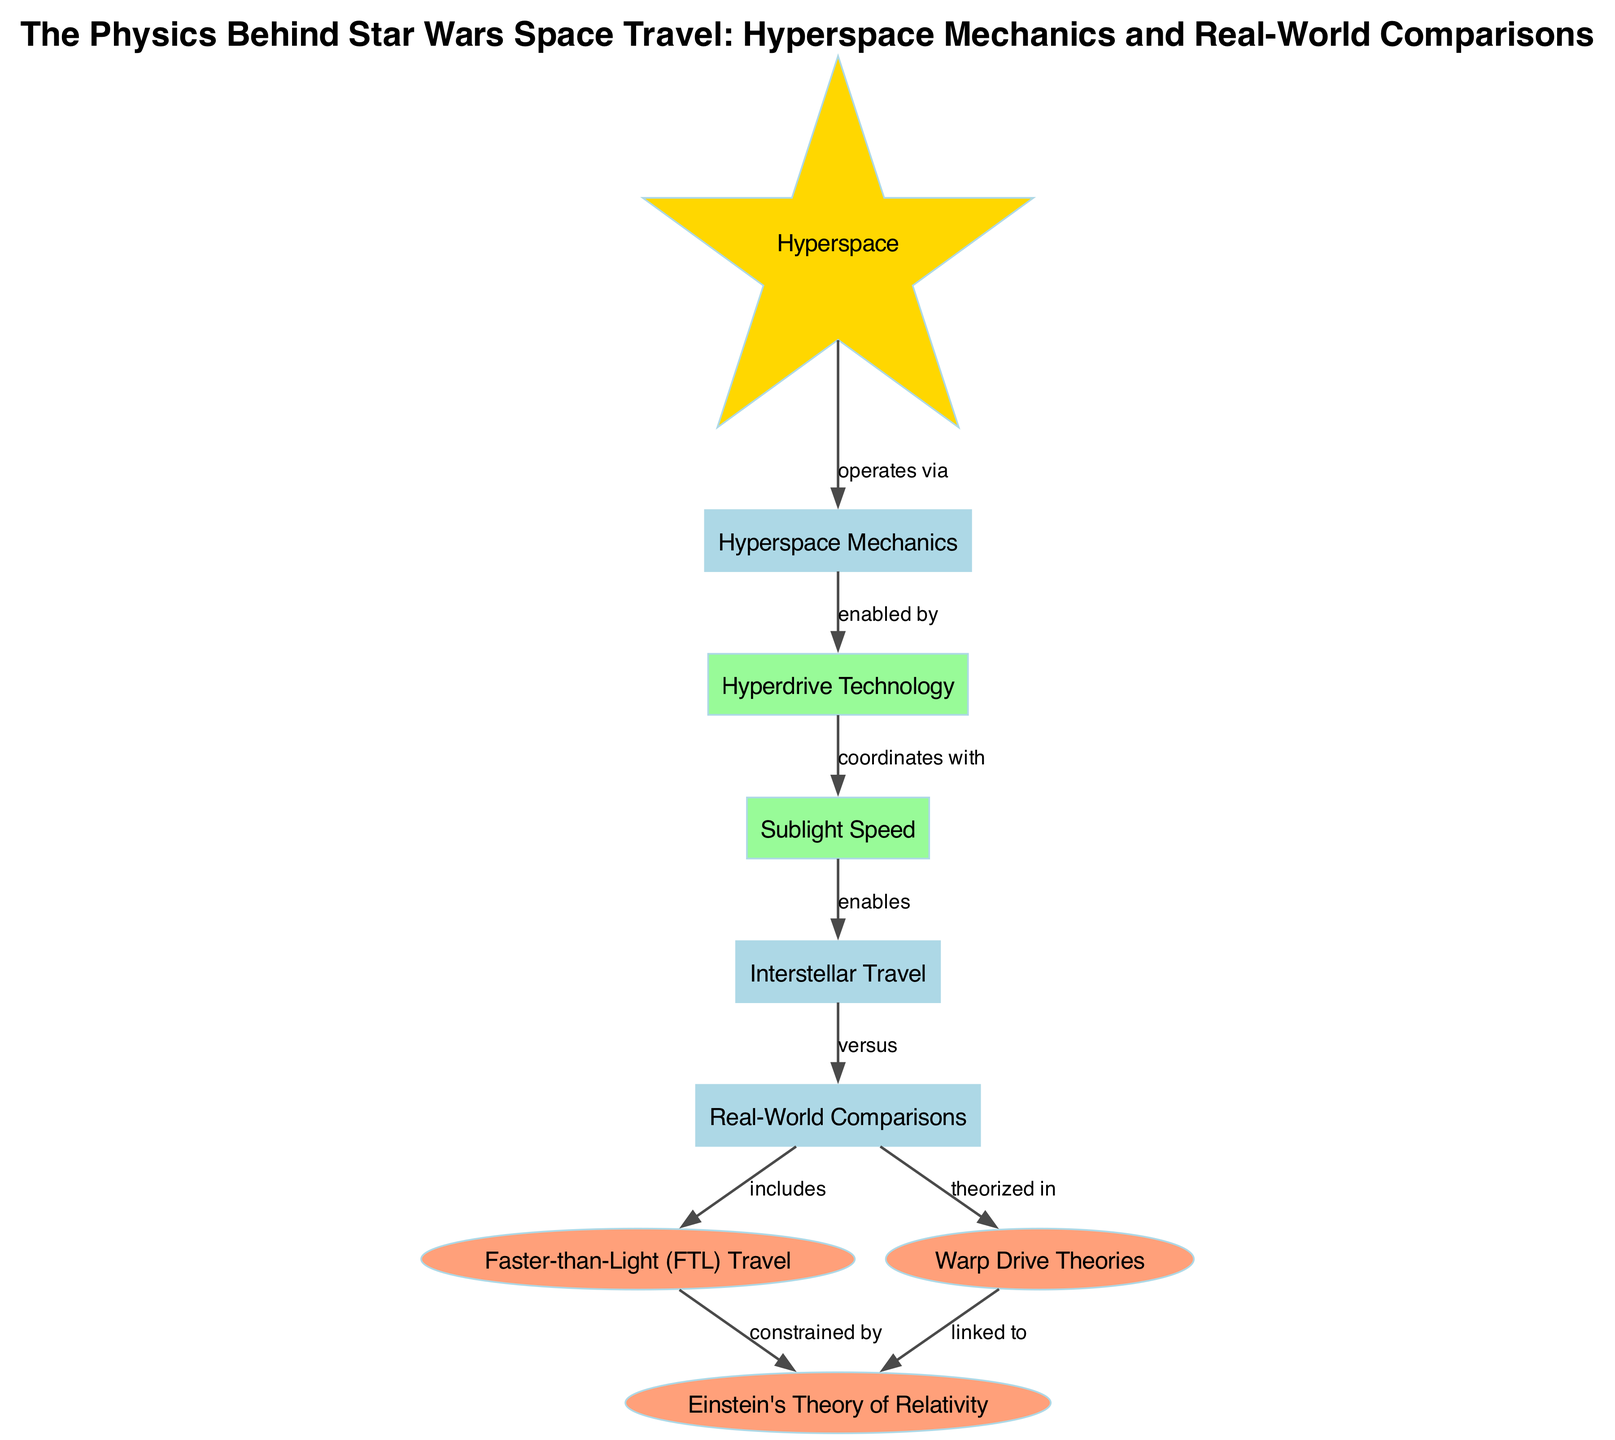What is the main concept represented at the top of the diagram? The top node of the diagram is labeled "Hyperspace," indicating it is the main concept or focus of the diagram.
Answer: Hyperspace How many nodes are present in the diagram? By counting each unique node listed, the diagram includes a total of 9 nodes, which represent different aspects of hyperspace and space travel.
Answer: 9 Which node is enabled by hyperspace mechanics? Referring to the edge that connects "hyperspace mechanics" to "hyperdrive technology," it indicates that hyperdrive technology is enabled by hyperspace mechanics.
Answer: Hyperdrive Technology What relationship connects sublight speed and interstellar travel? The edge between "sublight speed" and "interstellar travel" shows that sublight speed enables interstellar travel, illustrating the functionality of sublight speed in the process.
Answer: enables What concept constrains faster-than-light travel according to the diagram? The edge between "faster than light" and "Einstein's Theory of Relativity" indicates that faster-than-light travel is constrained by this theory, showing its relevance in the discussion of FTL travel.
Answer: Einstein's Theory of Relativity Which node theorizes the possibility of warp drive? The edge connecting "real-world comparisons" to "warp drive theories" shows that warp drive is theorized in the context of real-world comparisons to space travel.
Answer: theorized in What kind of travel is required before achieving interstellar travel? The edge from "hyperdrive technology" to "sublight speed" indicates that to achieve interstellar travel, hyperdrive technology must coordinate with sublight speed, suggesting a sequence in the travel process.
Answer: Sublight Speed Which two concepts are linked regarding warp drive? The connection between "warp drive" and "Einstein's Theory of Relativity" indicates that these two concepts are linked, highlighting a relationship with theoretical physics.
Answer: linked to Through how many edges does "faster than light" appear in the diagram? "Faster than light" has two edges connecting it to other nodes ("constrained by" and "includes"), indicating its position in the network of travel concepts.
Answer: 2 